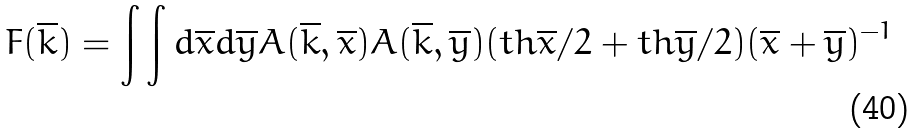<formula> <loc_0><loc_0><loc_500><loc_500>F ( \overline { k } ) = \int \int d \overline { x } d \overline { y } A ( \overline { k } , \overline { x } ) A ( \overline { k } , \overline { y } ) ( t h \overline { x } / 2 + t h \overline { y } / 2 ) ( \overline { x } + \overline { y } ) ^ { - 1 }</formula> 